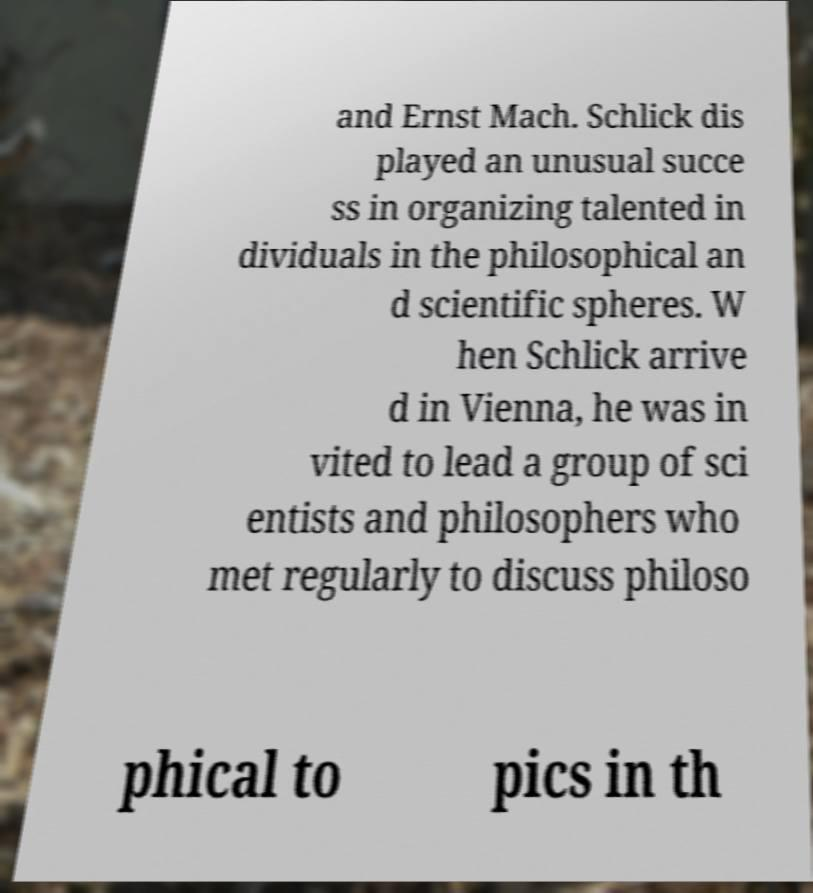Could you extract and type out the text from this image? and Ernst Mach. Schlick dis played an unusual succe ss in organizing talented in dividuals in the philosophical an d scientific spheres. W hen Schlick arrive d in Vienna, he was in vited to lead a group of sci entists and philosophers who met regularly to discuss philoso phical to pics in th 